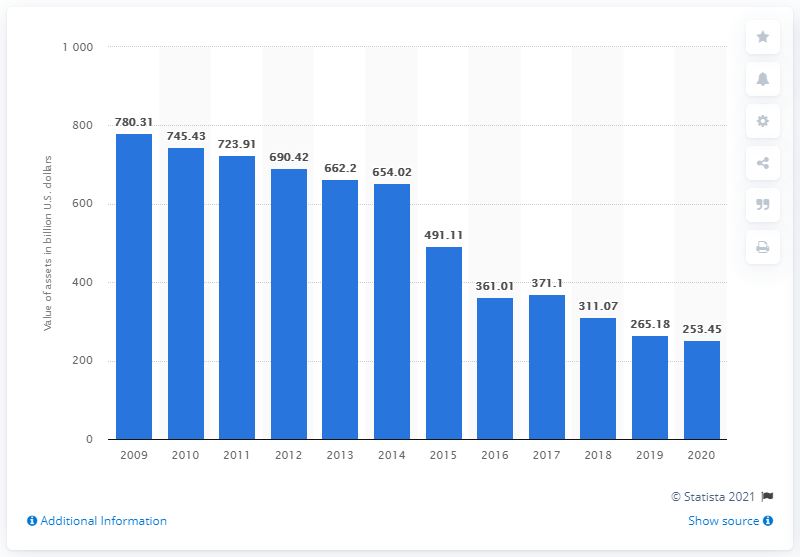List a handful of essential elements in this visual. General Electric's assets in the fiscal year of 2020 were 253.45... In the year 2009, General Electric's last fiscal year was. 